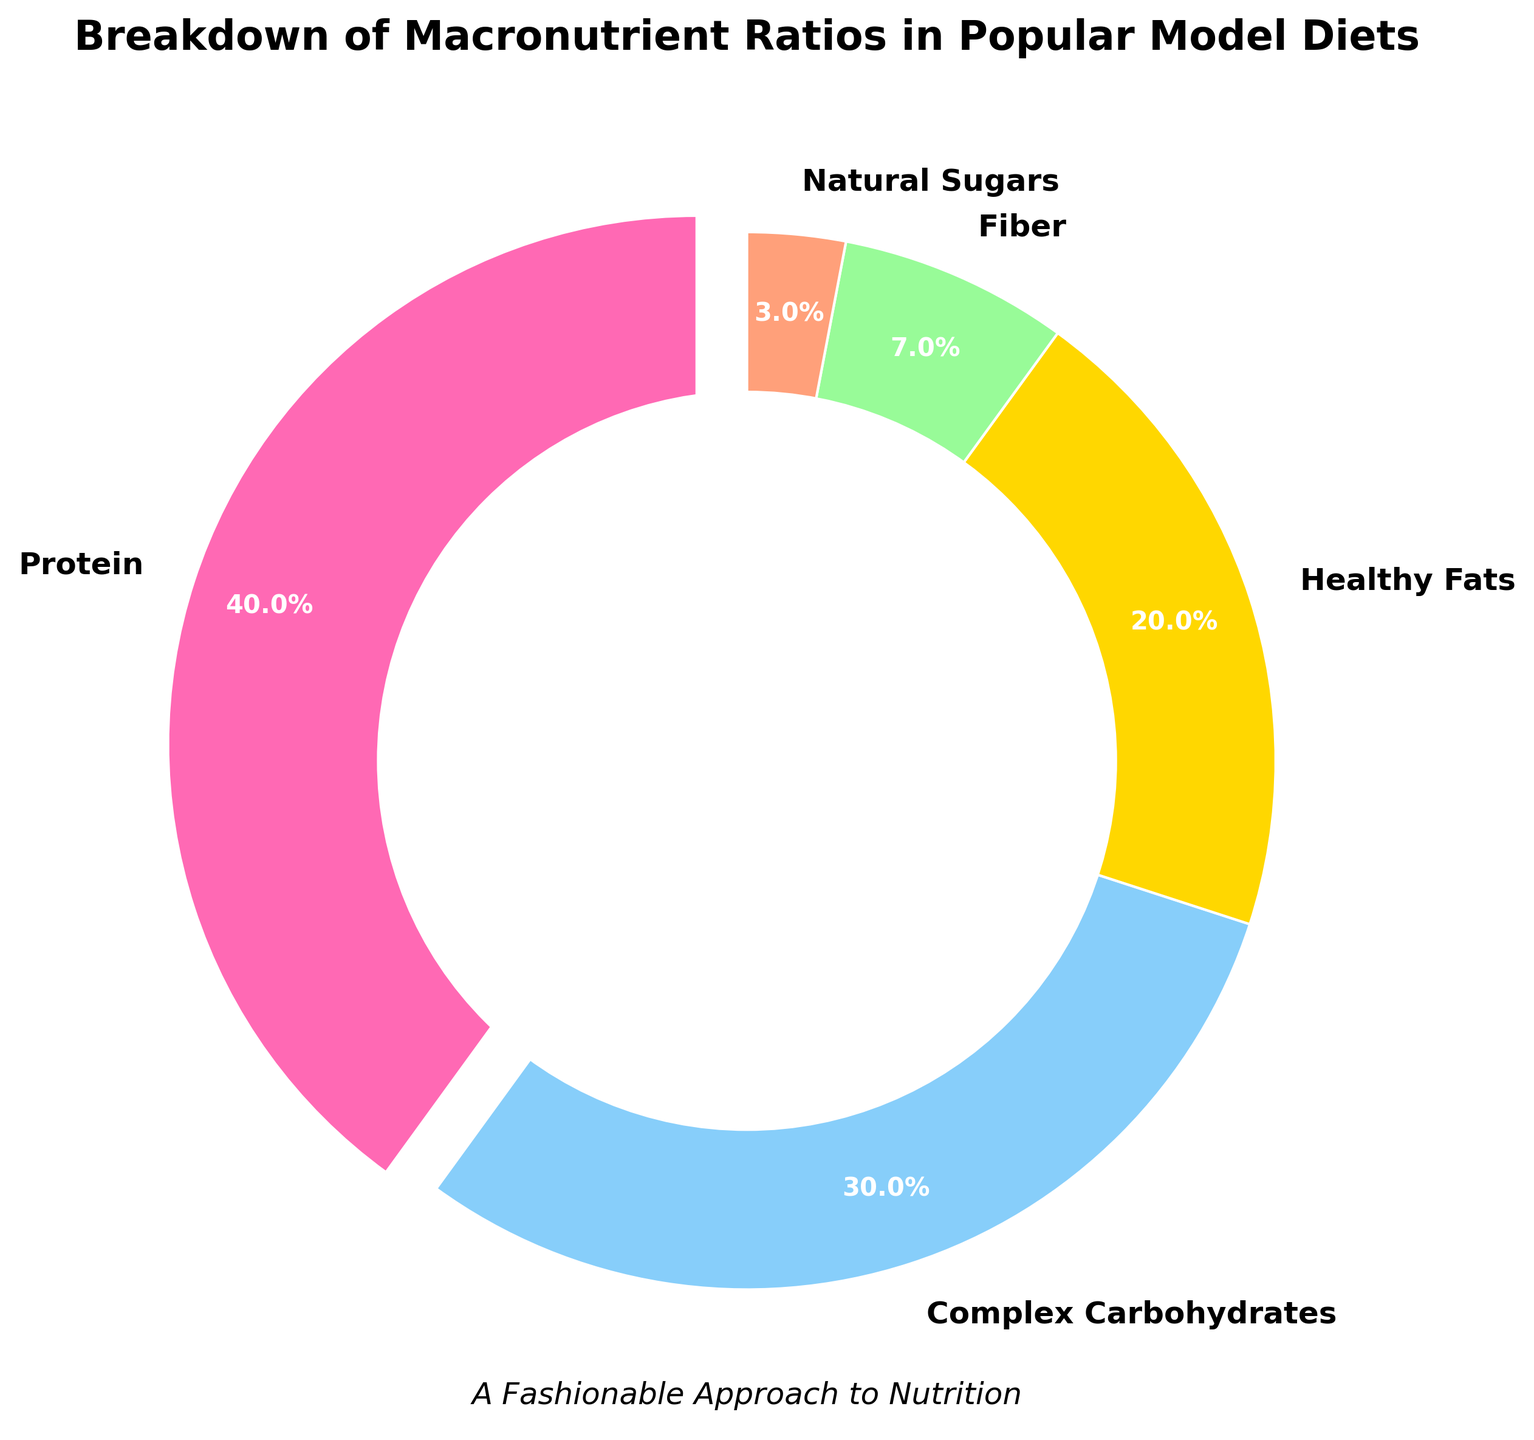What is the percentage of protein in the popular model diets? From the pie chart, the label "Protein" is associated with the largest wedge, and the percentage indicated on the chart for "Protein" is 40%.
Answer: 40% Which nutrient has the second-highest percentage in the model diets? From the pie chart, the nutrient with the second-largest wedge after "Protein" is "Complex Carbohydrates," with a percentage of 30%.
Answer: Complex Carbohydrates What is the combined percentage of Fiber and Natural Sugars in the model diets? According to the pie chart, Fiber accounts for 7% and Natural Sugars account for 3%. Summing these percentages yields a total of 7% + 3% = 10%.
Answer: 10% Are there more Healthy Fats or Complex Carbohydrates in the model diets? By comparing the wedges in the pie chart, Healthy Fats account for 20% while Complex Carbohydrates account for 30%. Thus, there are more Complex Carbohydrates.
Answer: Complex Carbohydrates Which macronutrient is represented by the pink slice in the pie chart? The pink slice in the pie chart corresponds to "Protein," as indicated by the color-coded legend.
Answer: Protein What is the total percentage contribution of Protein, Complex Carbohydrates, and Healthy Fats in model diets? From the pie chart, the percentage of Protein is 40%, Complex Carbohydrates is 30%, and Healthy Fats is 20%. Summing these percentages: 40% + 30% + 20% = 90%.
Answer: 90% How does the percentage of Healthy Fats compare to the percentage of Fiber in the model diets? In the pie chart, Healthy Fats have a percentage of 20%, whereas Fiber has a percentage of 7%. Therefore, Healthy Fats have a greater percentage than Fiber by 20% - 7% = 13%.
Answer: 13% What macronutrient makes up the smallest percentage of the model diets? By looking at the pie chart, the smallest wedge represents Natural Sugars, which makes up 3% of the model diets.
Answer: Natural Sugars 